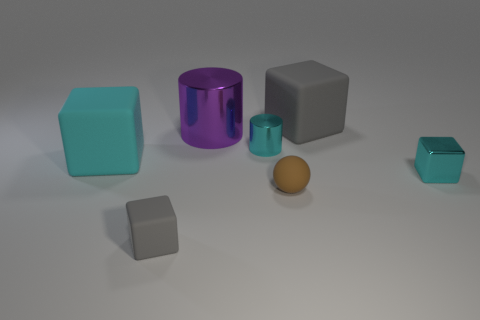Add 2 matte balls. How many objects exist? 9 Subtract all small cyan cubes. How many cubes are left? 3 Subtract all purple cylinders. How many cylinders are left? 1 Subtract all balls. How many objects are left? 6 Subtract all red cylinders. How many purple spheres are left? 0 Subtract all tiny green rubber blocks. Subtract all tiny shiny things. How many objects are left? 5 Add 3 large purple objects. How many large purple objects are left? 4 Add 2 small cyan metallic cylinders. How many small cyan metallic cylinders exist? 3 Subtract 0 cyan balls. How many objects are left? 7 Subtract 1 spheres. How many spheres are left? 0 